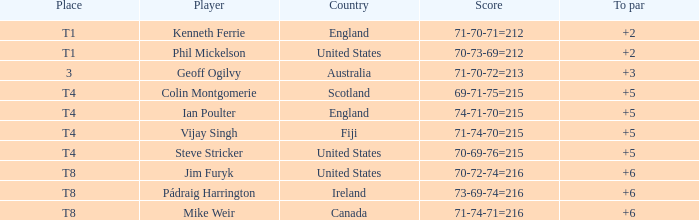Who was the competitor at the rank of t1 in to par with a score of 70-73-69=212? 2.0. 